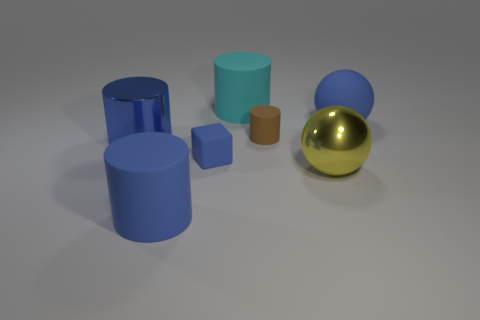Subtract all large metallic cylinders. How many cylinders are left? 3 Subtract all gray blocks. How many blue cylinders are left? 2 Add 2 metal spheres. How many objects exist? 9 Subtract all brown cylinders. How many cylinders are left? 3 Subtract 1 balls. How many balls are left? 1 Subtract all cylinders. How many objects are left? 3 Subtract all brown balls. Subtract all small brown things. How many objects are left? 6 Add 2 matte cubes. How many matte cubes are left? 3 Add 5 big cyan spheres. How many big cyan spheres exist? 5 Subtract 0 cyan balls. How many objects are left? 7 